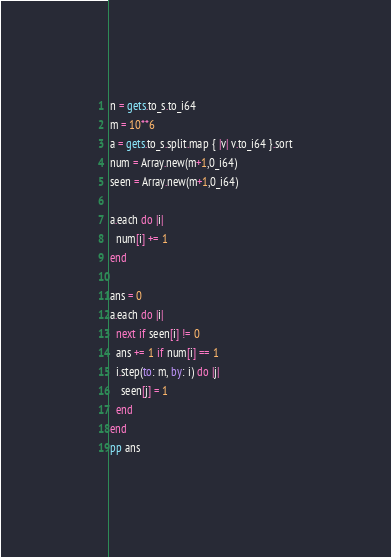<code> <loc_0><loc_0><loc_500><loc_500><_Crystal_>n = gets.to_s.to_i64
m = 10**6
a = gets.to_s.split.map { |v| v.to_i64 }.sort
num = Array.new(m+1,0_i64)
seen = Array.new(m+1,0_i64)

a.each do |i|
  num[i] += 1
end

ans = 0
a.each do |i|
  next if seen[i] != 0
  ans += 1 if num[i] == 1
  i.step(to: m, by: i) do |j|
    seen[j] = 1 
  end
end
pp ans</code> 